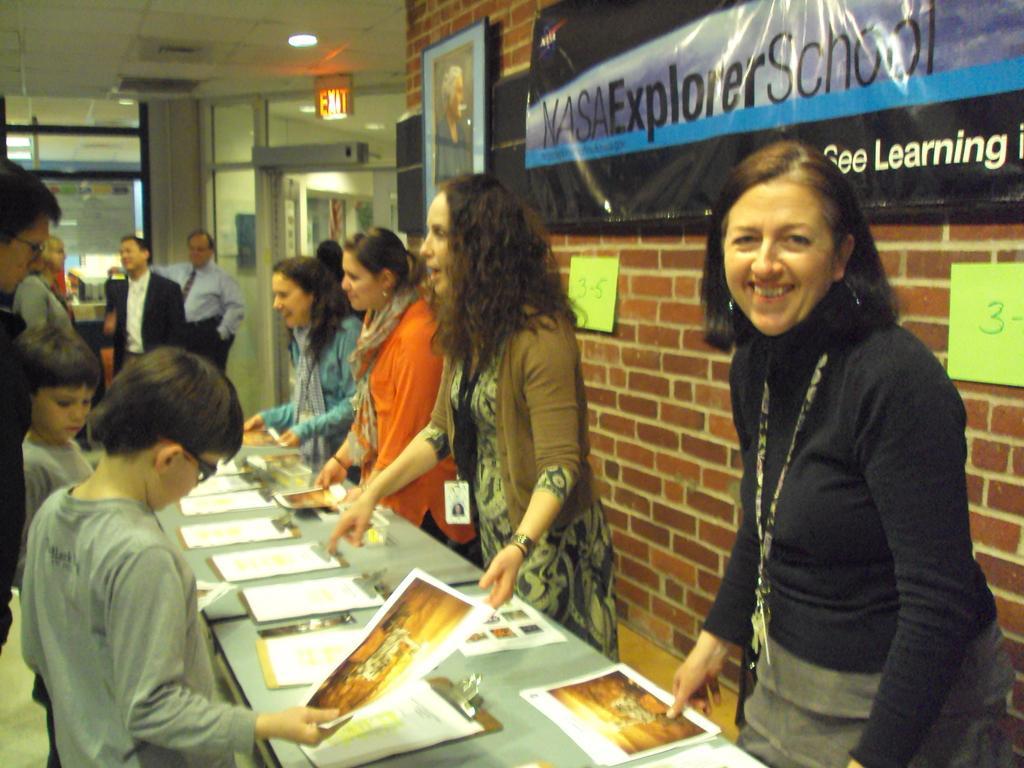Please provide a concise description of this image. In the image we can see there are people standing and there are papers kept on the pads. The papers are kept on the table and the people are wearing id cards. There are banners and photo frames kept on the wall and the wall is made up of red bricks. There is a sign board on the roof and its written ¨Exit¨. 